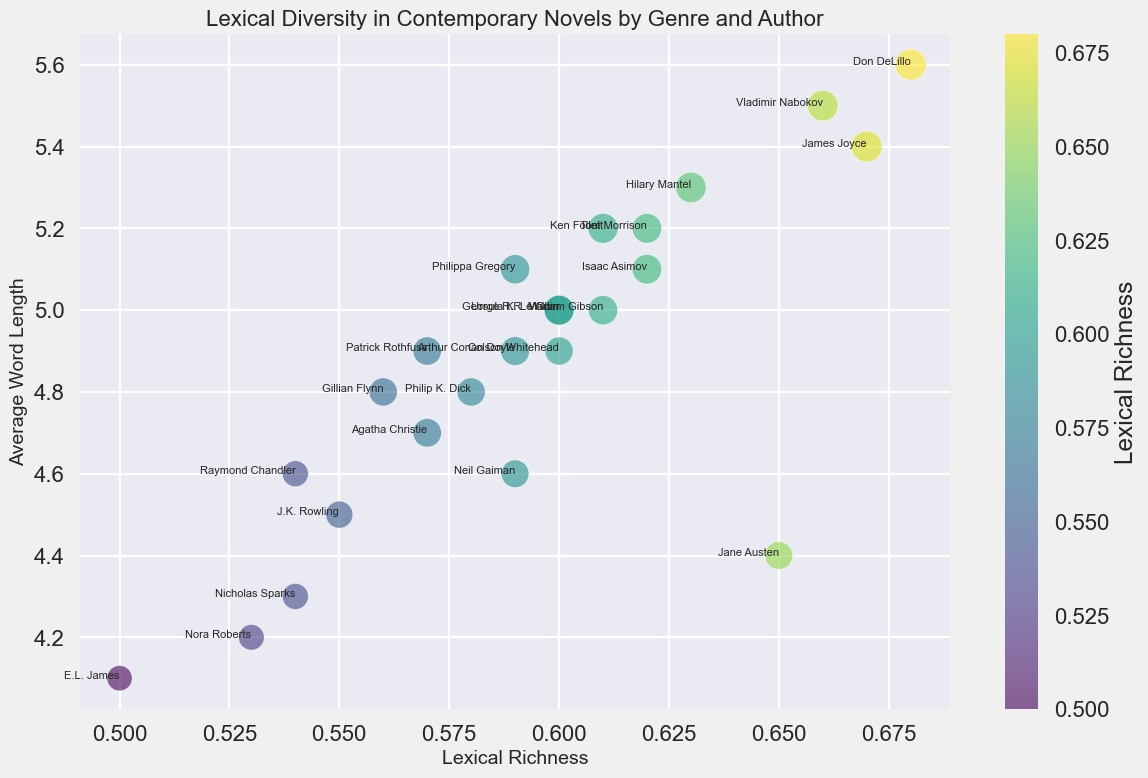What is the lexical richness of Don DeLillo's novels, and how does it compare to Jane Austen's novels? Don DeLillo's novels have a lexical richness of 0.68, while Jane Austen's novels have a lexical richness of 0.65. By comparing these values, we can see that Don DeLillo's novels have a slightly higher lexical richness.
Answer: Don DeLillo: 0.68, Jane Austen: 0.65 Which author has the longest average word length, and in which genre do they write? By looking at the "Average Word Length" attribute, we can see that Vladimir Nabokov has the longest average word length of 5.5. He writes in the literary genre.
Answer: Vladimir Nabokov, Literary Who are the authors that fall within the fantasy genre, and how do their lexical richness values compare? Authors in the fantasy genre are J.K. Rowling, George R.R. Martin, Neil Gaiman, and Patrick Rothfuss. Their lexical richness values are 0.55, 0.60, 0.59, and 0.57 respectively. By comparing these values, George R.R. Martin has the highest lexical richness, followed by Neil Gaiman, Patrick Rothfuss, and then J.K. Rowling.
Answer: J.K. Rowling: 0.55, George R.R. Martin: 0.60, Neil Gaiman: 0.59, Patrick Rothfuss: 0.57 Which genre boasts the author with the highest number of unique words, and who is the author? From the bubble sizes, which correspond to the "Number of Unique Words," we can see that Don DeLillo (Literary genre) has the highest number of unique words with 5000.
Answer: Literary, Don DeLillo What are the main visual characteristics used to differentiate the data points in the plot? The data points in the plot use color, size, and labels to differentiate. Color varies with lexical richness, size represents the number of unique words, and author names are labeled at each point. These visual characteristics help comprehend differences and similarities across genres and authors.
Answer: Color, size, labels Which literary author has a higher average word length: James Joyce or Vladimir Nabokov? James Joyce has an average word length of 5.4 and Vladimir Nabokov has an average word length of 5.5. By comparing these values, Vladimir Nabokov has a higher average word length.
Answer: Vladimir Nabokov Identify two authors from different genres with the same average word length. Isaac Asimov (Science Fiction) and George R.R. Martin (Fantasy) both have an average word length of 5.0.
Answer: Isaac Asimov, George R.R. Martin What is the range of lexical richness values among authors in the mystery genre? For mystery authors: Agatha Christie (0.57), Arthur Conan Doyle (0.59), Gillian Flynn (0.56), and Raymond Chandler (0.54), the highest lexical richness is 0.59, and the lowest is 0.54. The range is the difference between these values, which is 0.59 - 0.54 = 0.05.
Answer: 0.05 